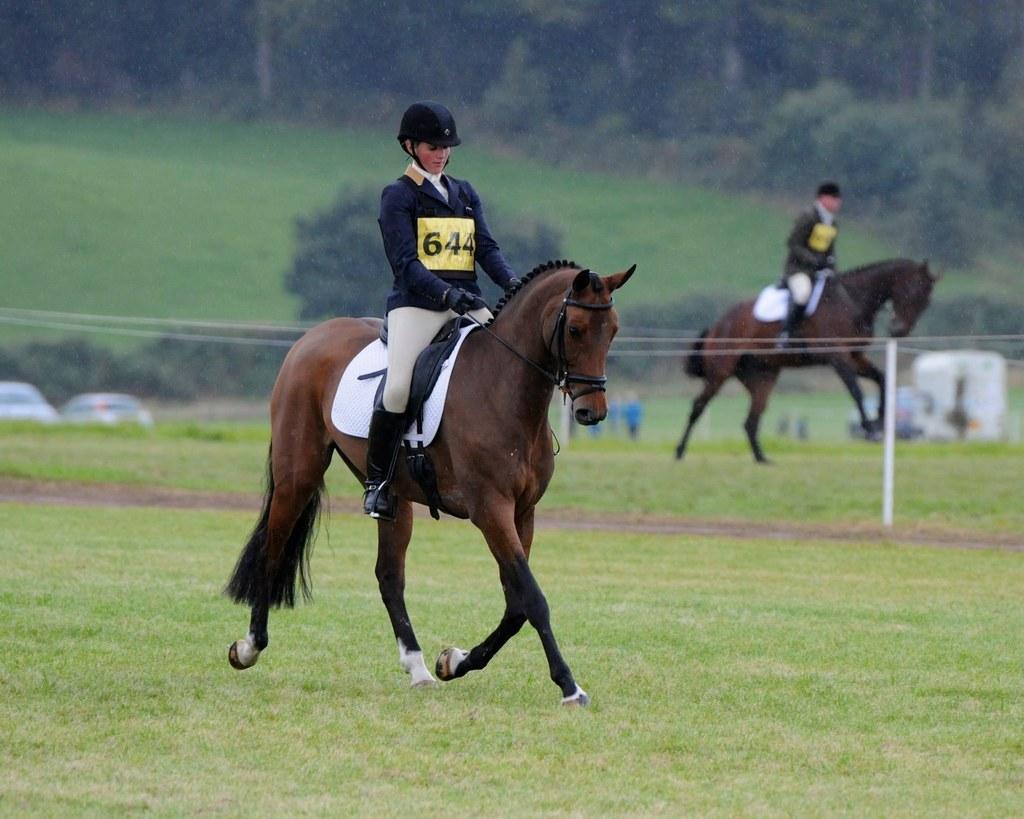Could you give a brief overview of what you see in this image? In this picture we can see the woman sitting on the brown horse and riding in the ground. Behind there is a grass lawn and some trees. 